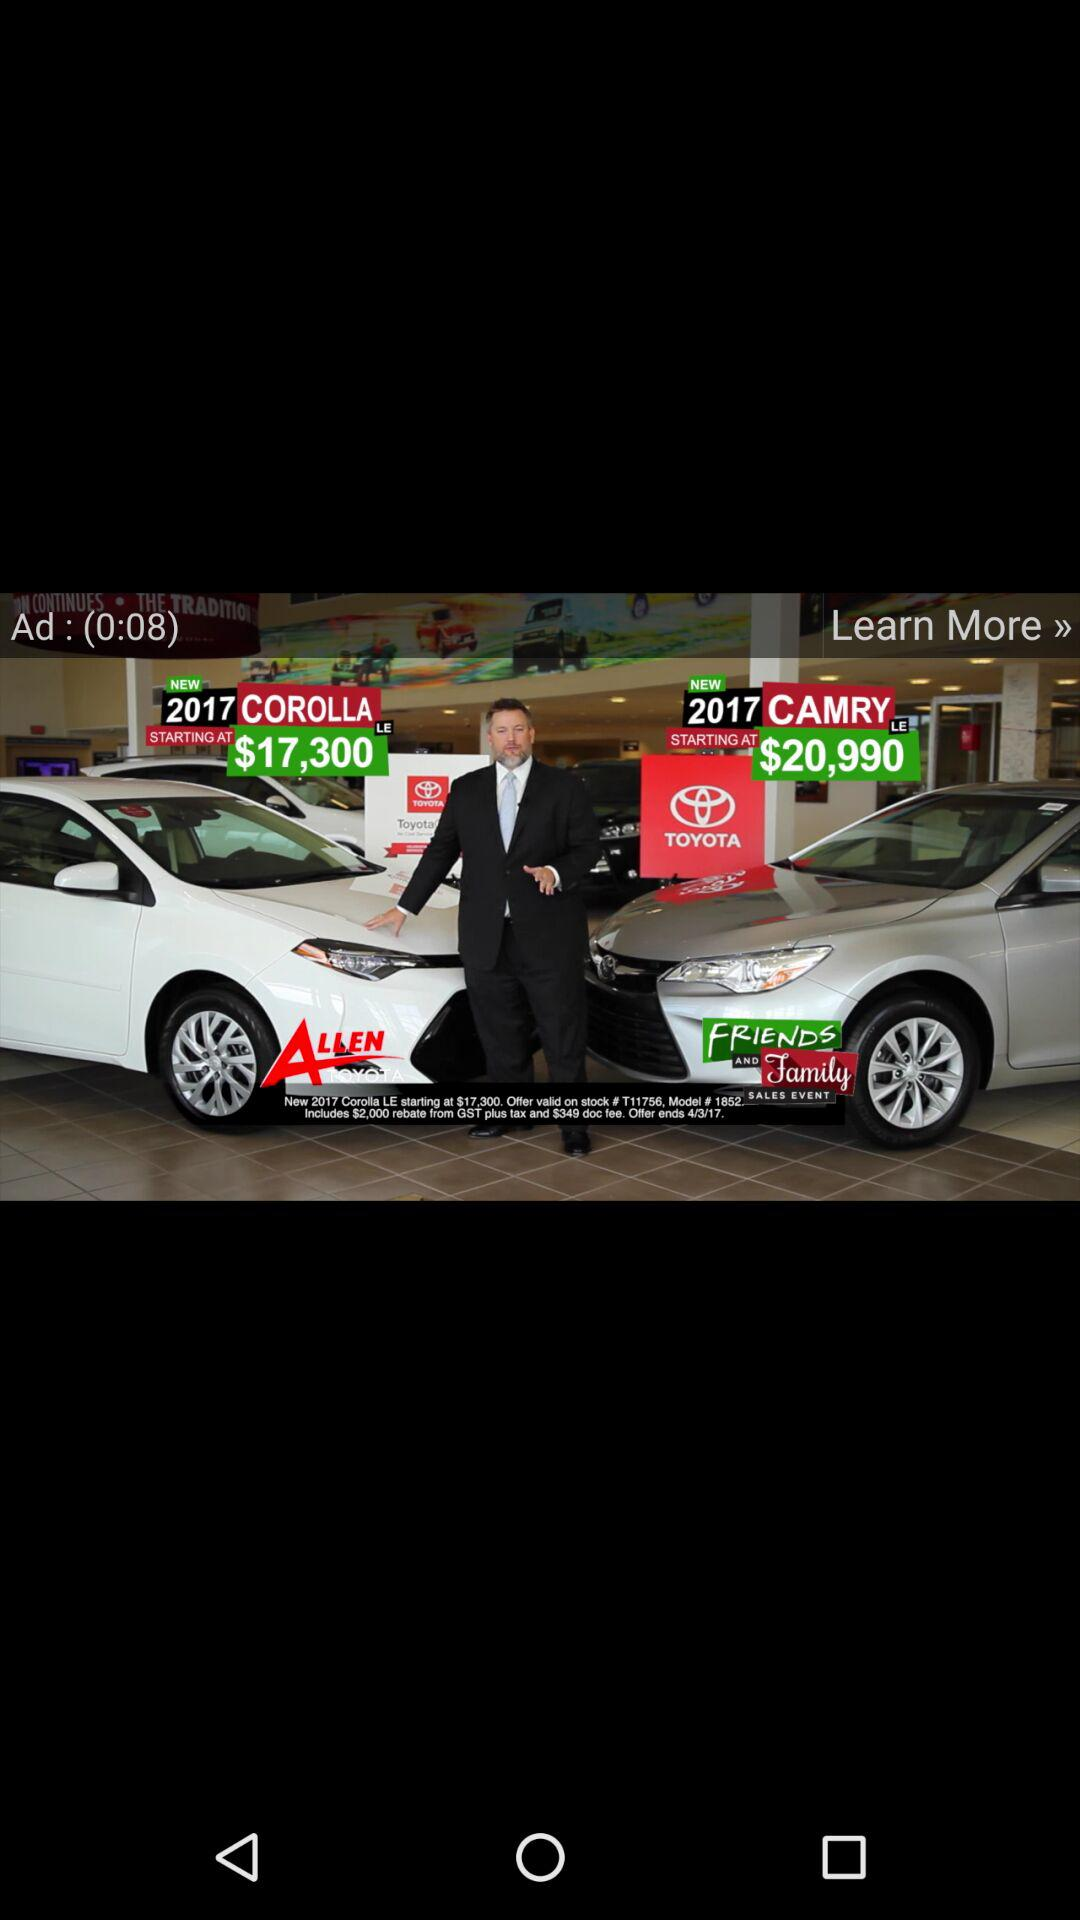How much more does the Camry cost than the Corolla?
Answer the question using a single word or phrase. $3690 